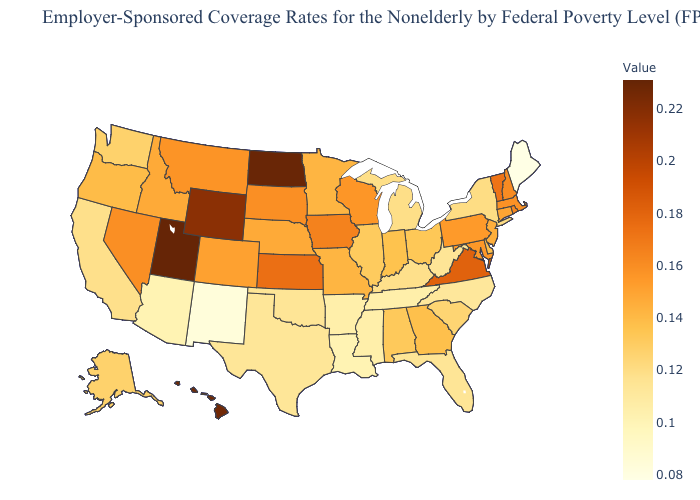Among the states that border Wyoming , does Utah have the lowest value?
Keep it brief. No. Which states hav the highest value in the West?
Answer briefly. Utah. Among the states that border Texas , which have the highest value?
Quick response, please. Oklahoma. Among the states that border Indiana , which have the highest value?
Write a very short answer. Ohio. Does Utah have the highest value in the USA?
Keep it brief. Yes. Does Idaho have a lower value than Utah?
Answer briefly. Yes. 